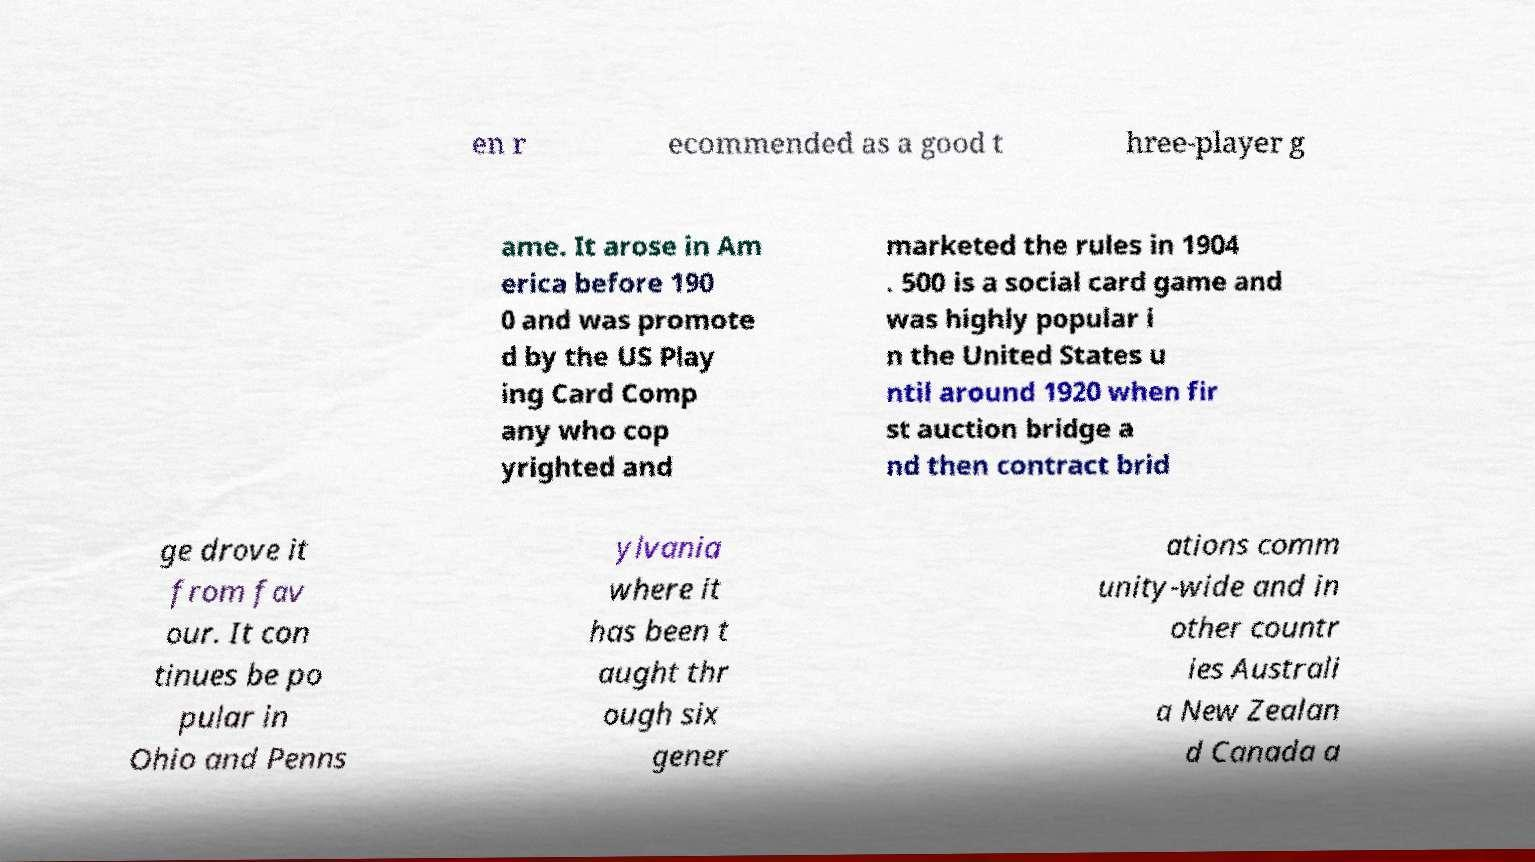For documentation purposes, I need the text within this image transcribed. Could you provide that? en r ecommended as a good t hree-player g ame. It arose in Am erica before 190 0 and was promote d by the US Play ing Card Comp any who cop yrighted and marketed the rules in 1904 . 500 is a social card game and was highly popular i n the United States u ntil around 1920 when fir st auction bridge a nd then contract brid ge drove it from fav our. It con tinues be po pular in Ohio and Penns ylvania where it has been t aught thr ough six gener ations comm unity-wide and in other countr ies Australi a New Zealan d Canada a 